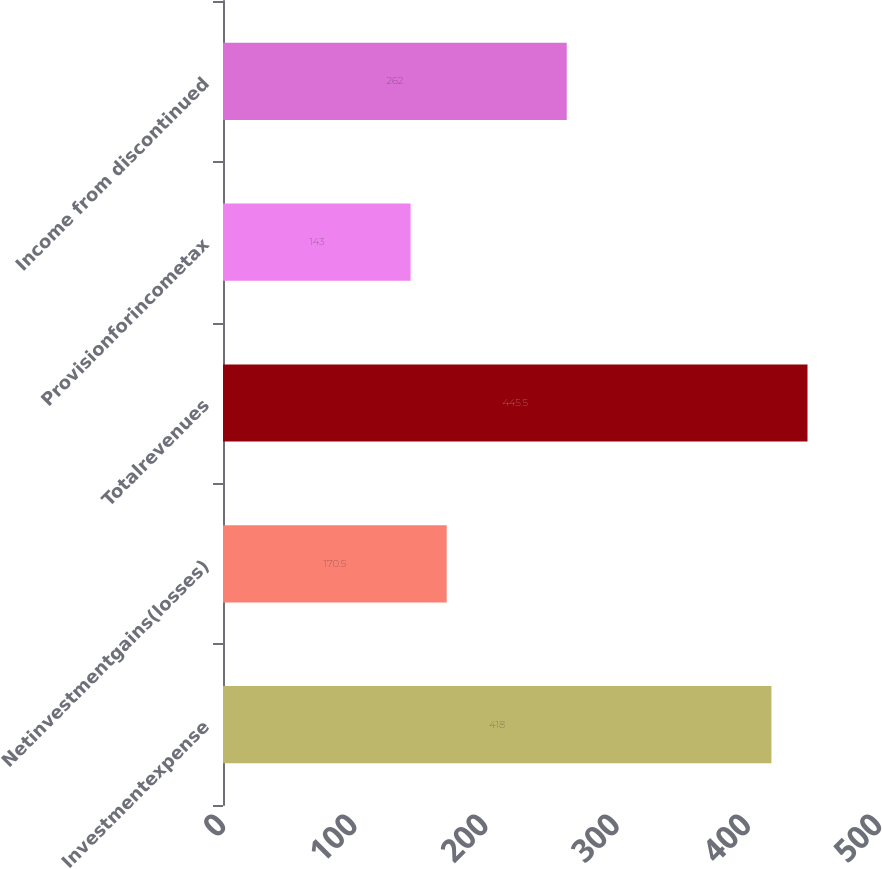<chart> <loc_0><loc_0><loc_500><loc_500><bar_chart><fcel>Investmentexpense<fcel>Netinvestmentgains(losses)<fcel>Totalrevenues<fcel>Provisionforincometax<fcel>Income from discontinued<nl><fcel>418<fcel>170.5<fcel>445.5<fcel>143<fcel>262<nl></chart> 